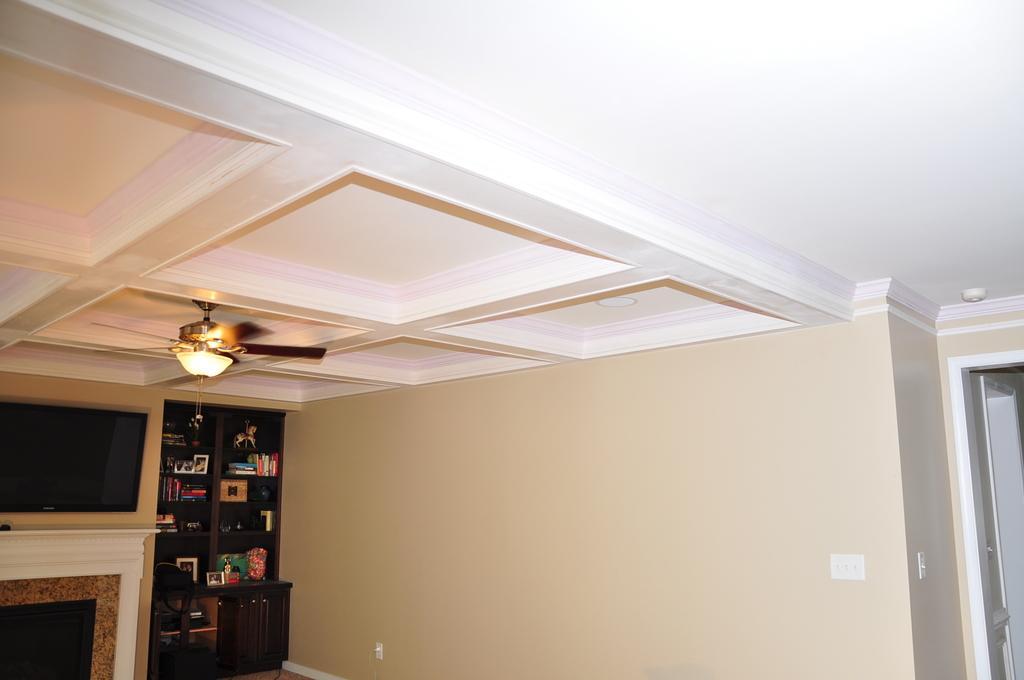In one or two sentences, can you explain what this image depicts? In this picture we observe a upper portion of a house where there is a television, a cupboard filled with books and a fan fitted to the roof. 